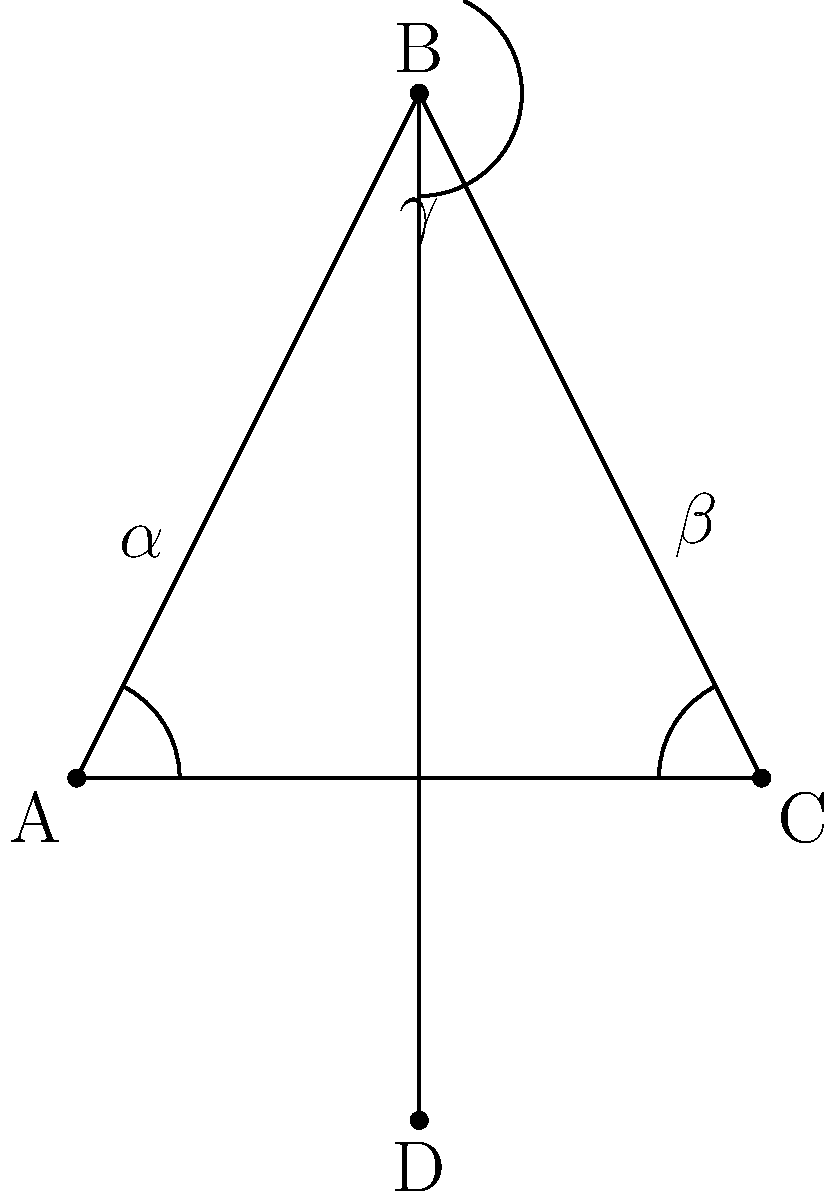In the context of a classical theatrical bow, consider the stick figure diagram representing an actor's posture. If angle $\alpha$ represents the bend at the hips, $\beta$ the bend at the knees, and $\gamma$ the angle between the upper body and the extended arm, what is the relationship between these angles that would create the most aesthetically pleasing and dramatically effective bow, according to traditional stage conventions? To determine the relationship between angles $\alpha$, $\beta$, and $\gamma$ for the most aesthetically pleasing and dramatically effective theatrical bow, we need to consider several factors:

1. Historical context: Classical theatre often emphasized grace and formality in movement.

2. Body alignment: A well-executed bow requires proper balance and control.

3. Visibility to the audience: The actor's face should remain partially visible during the bow.

4. Dramatic effect: The bow should convey respect and gratitude to the audience.

Given these considerations:

1. Angle $\alpha$ (hip bend) should be approximately 45°. This allows for a deep enough bow to show respect while maintaining some visibility of the actor's face.

2. Angle $\beta$ (knee bend) should be about 15°-20°. A slight bend in the knees provides stability and grace to the movement.

3. Angle $\gamma$ (arm extension) should be around 90°. This creates an elegant line from the shoulder to the hand, framing the body's bow.

The relationship between these angles can be expressed as:

$$\alpha \approx 2\beta + \frac{\gamma}{2}$$

This relationship ensures that the bow is deep enough (controlled by $\alpha$), stable (influenced by $\beta$), and elegantly framed (determined by $\gamma$).
Answer: $\alpha \approx 2\beta + \frac{\gamma}{2}$ 